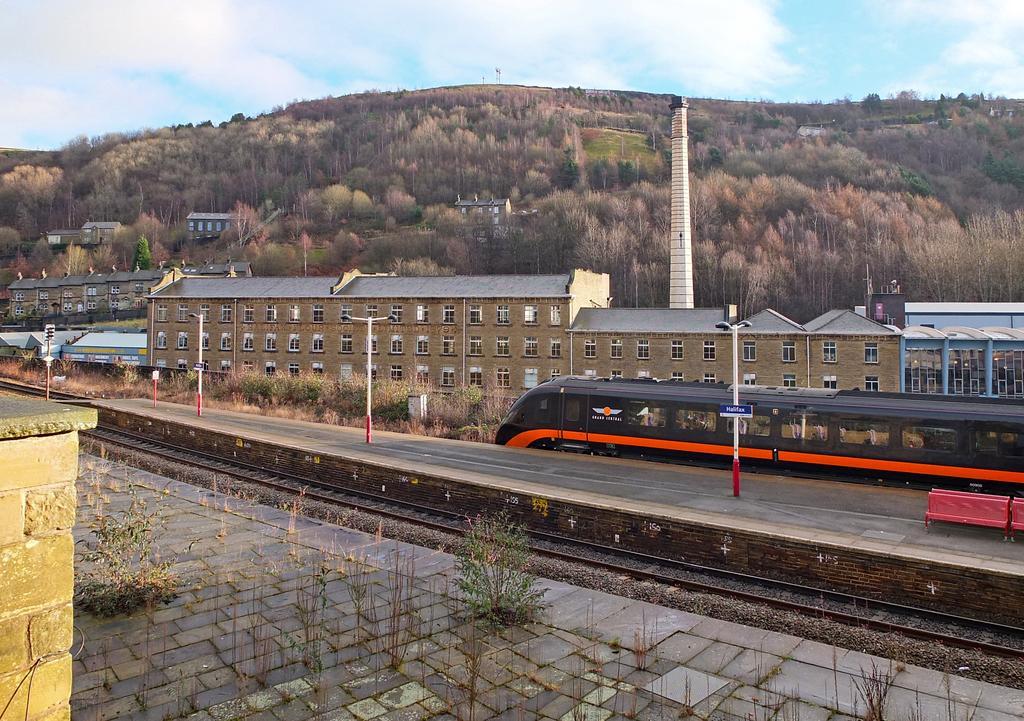How would you summarize this image in a sentence or two? On the left side of the image there is a rock wall, in front of the wall there is are plants on the platform, in front of the platform, there is a train track, beside the track on the platform there are lamp posts with name boards, beside the lamp posts there are benches, behind the lamp posts there is a train, on the other side of the train there are plants, electrical boxes, signal lights, buildings, tower, in the background of the image there are trees and mountains, at the top of the image there are clouds in the sky. 